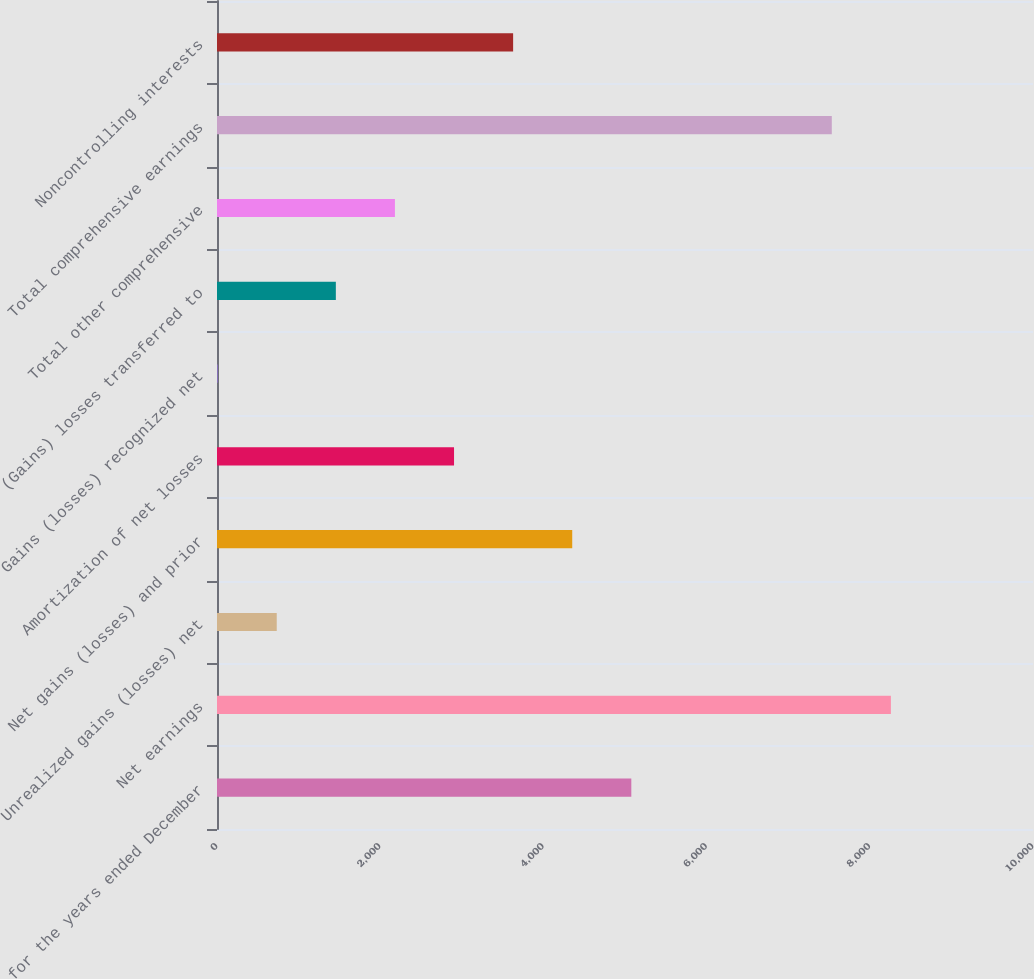Convert chart to OTSL. <chart><loc_0><loc_0><loc_500><loc_500><bar_chart><fcel>for the years ended December<fcel>Net earnings<fcel>Unrealized gains (losses) net<fcel>Net gains (losses) and prior<fcel>Amortization of net losses<fcel>Gains (losses) recognized net<fcel>(Gains) losses transferred to<fcel>Total other comprehensive<fcel>Total comprehensive earnings<fcel>Noncontrolling interests<nl><fcel>5077.4<fcel>8258.4<fcel>732.2<fcel>4353.2<fcel>2904.8<fcel>8<fcel>1456.4<fcel>2180.6<fcel>7534.2<fcel>3629<nl></chart> 